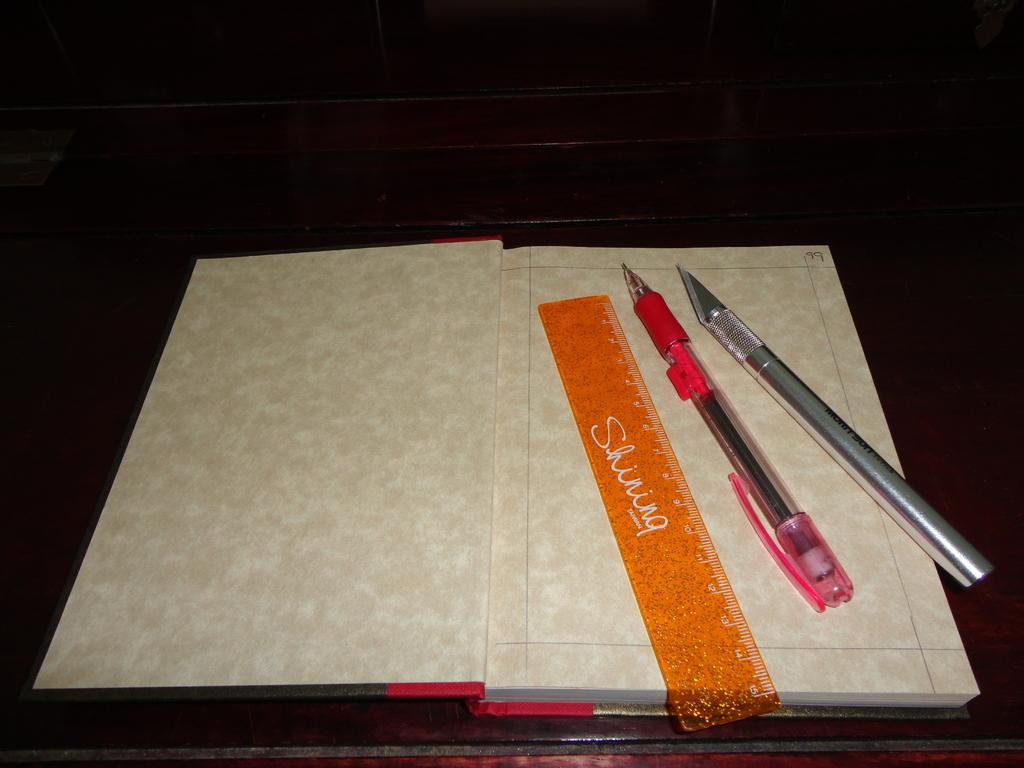What object is placed on the platform in the image? There is a book on a platform in the image. What other objects are on the platform? There is a scale and pens on the platform. What type of comb can be seen in the image? There is no comb present in the image. How does the moon affect the objects on the platform in the image? The moon is not present in the image, so it cannot affect the objects on the platform. 